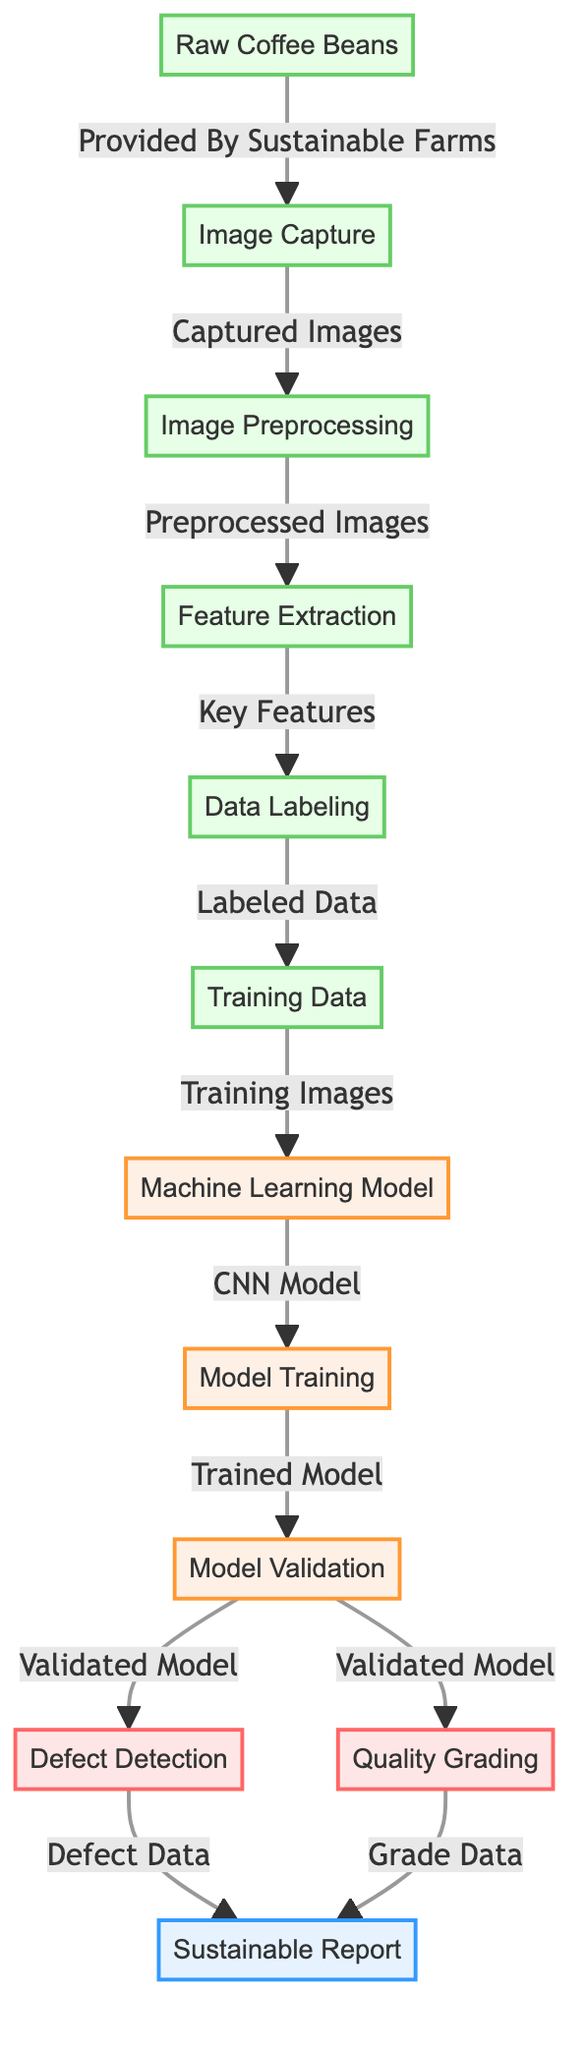What is the first process in the diagram? The first process in the diagram is "Image Capture," which is the initial step after the "Raw Coffee Beans" are provided by sustainable farms.
Answer: Image Capture How many processes are depicted in the diagram? The diagram shows three processes: "Defect Detection," "Quality Grading," and "Sustainable Report."
Answer: Three Which node follows "Image Preprocessing"? The node that follows "Image Preprocessing" is "Feature Extraction."
Answer: Feature Extraction What type of model is used in the training phase? The training phase uses a "CNN Model," which is a type of machine learning model known for image analysis.
Answer: CNN Model How do "Defect Detection" and "Quality Grading" connect to the "Sustainable Report"? Both "Defect Detection" and "Quality Grading" have outputs that lead to the "Sustainable Report," indicating they contribute to the final reporting process.
Answer: Both contribute What is the relationship between "Model Validation" and "Defect Detection"? "Model Validation" is a preceding step to "Defect Detection," meaning the model must be validated before it can be used to detect defects.
Answer: Preceding step What type of information is labeled during the "Data Labeling" process? During the "Data Labeling" process, the information being labeled is "Labeled Data" which refers to the images that have been labeled with their respective features.
Answer: Labeled Data What is the outcome after the "Model Training" phase? The outcome after the "Model Training" phase is a "Trained Model," which is the result of applying training on the CNN model with the training data.
Answer: Trained Model Which process occurs after "Training Data"? The process that occurs after "Training Data" is "Machine Learning Model."
Answer: Machine Learning Model 